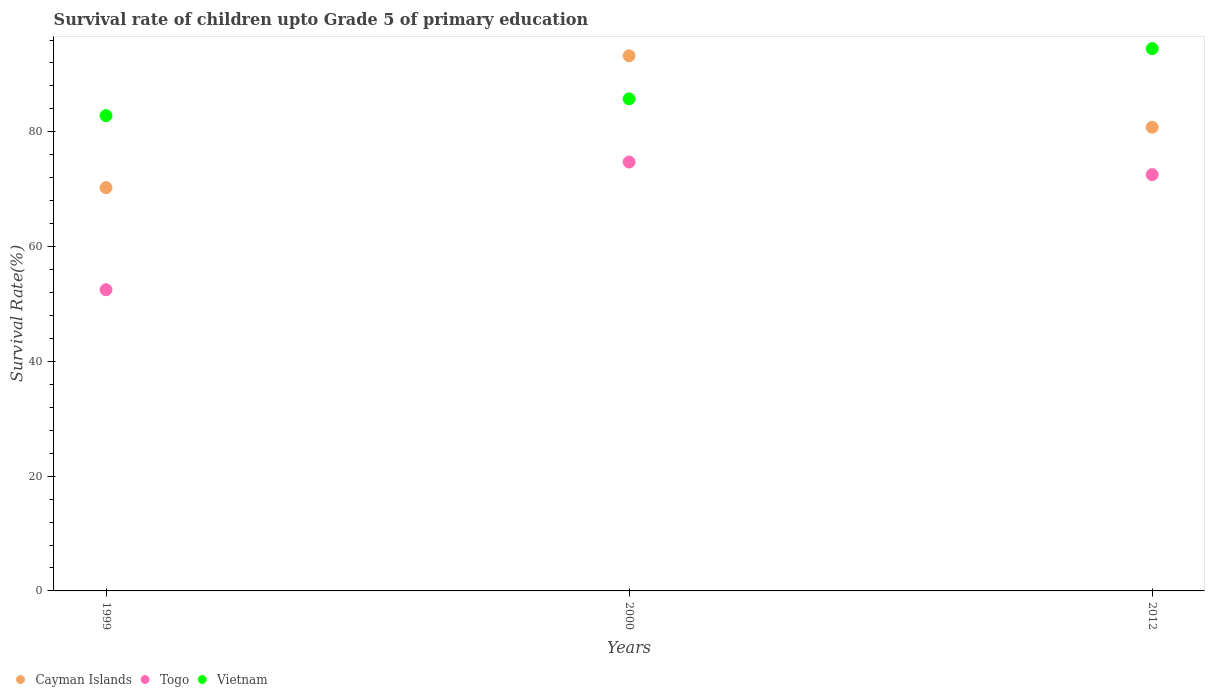Is the number of dotlines equal to the number of legend labels?
Make the answer very short. Yes. What is the survival rate of children in Cayman Islands in 1999?
Provide a succinct answer. 70.28. Across all years, what is the maximum survival rate of children in Togo?
Offer a very short reply. 74.74. Across all years, what is the minimum survival rate of children in Cayman Islands?
Keep it short and to the point. 70.28. In which year was the survival rate of children in Vietnam maximum?
Offer a terse response. 2012. In which year was the survival rate of children in Cayman Islands minimum?
Keep it short and to the point. 1999. What is the total survival rate of children in Vietnam in the graph?
Your answer should be very brief. 263.06. What is the difference between the survival rate of children in Vietnam in 2000 and that in 2012?
Provide a succinct answer. -8.76. What is the difference between the survival rate of children in Togo in 1999 and the survival rate of children in Vietnam in 2000?
Your answer should be very brief. -33.26. What is the average survival rate of children in Vietnam per year?
Your answer should be very brief. 87.69. In the year 2000, what is the difference between the survival rate of children in Cayman Islands and survival rate of children in Vietnam?
Offer a very short reply. 7.5. In how many years, is the survival rate of children in Vietnam greater than 80 %?
Your response must be concise. 3. What is the ratio of the survival rate of children in Vietnam in 1999 to that in 2012?
Make the answer very short. 0.88. Is the survival rate of children in Cayman Islands in 2000 less than that in 2012?
Give a very brief answer. No. Is the difference between the survival rate of children in Cayman Islands in 2000 and 2012 greater than the difference between the survival rate of children in Vietnam in 2000 and 2012?
Ensure brevity in your answer.  Yes. What is the difference between the highest and the second highest survival rate of children in Togo?
Offer a terse response. 2.2. What is the difference between the highest and the lowest survival rate of children in Vietnam?
Offer a terse response. 11.68. In how many years, is the survival rate of children in Cayman Islands greater than the average survival rate of children in Cayman Islands taken over all years?
Your response must be concise. 1. Is the survival rate of children in Vietnam strictly greater than the survival rate of children in Cayman Islands over the years?
Keep it short and to the point. No. Is the survival rate of children in Togo strictly less than the survival rate of children in Vietnam over the years?
Your answer should be compact. Yes. Does the graph contain grids?
Your response must be concise. No. Where does the legend appear in the graph?
Ensure brevity in your answer.  Bottom left. How many legend labels are there?
Your answer should be very brief. 3. How are the legend labels stacked?
Ensure brevity in your answer.  Horizontal. What is the title of the graph?
Keep it short and to the point. Survival rate of children upto Grade 5 of primary education. Does "Czech Republic" appear as one of the legend labels in the graph?
Give a very brief answer. No. What is the label or title of the Y-axis?
Offer a terse response. Survival Rate(%). What is the Survival Rate(%) of Cayman Islands in 1999?
Make the answer very short. 70.28. What is the Survival Rate(%) in Togo in 1999?
Provide a succinct answer. 52.48. What is the Survival Rate(%) of Vietnam in 1999?
Provide a short and direct response. 82.82. What is the Survival Rate(%) of Cayman Islands in 2000?
Make the answer very short. 93.25. What is the Survival Rate(%) in Togo in 2000?
Your answer should be very brief. 74.74. What is the Survival Rate(%) of Vietnam in 2000?
Your answer should be compact. 85.74. What is the Survival Rate(%) of Cayman Islands in 2012?
Ensure brevity in your answer.  80.8. What is the Survival Rate(%) in Togo in 2012?
Make the answer very short. 72.54. What is the Survival Rate(%) in Vietnam in 2012?
Your answer should be very brief. 94.5. Across all years, what is the maximum Survival Rate(%) of Cayman Islands?
Give a very brief answer. 93.25. Across all years, what is the maximum Survival Rate(%) of Togo?
Offer a terse response. 74.74. Across all years, what is the maximum Survival Rate(%) of Vietnam?
Offer a terse response. 94.5. Across all years, what is the minimum Survival Rate(%) in Cayman Islands?
Your response must be concise. 70.28. Across all years, what is the minimum Survival Rate(%) in Togo?
Make the answer very short. 52.48. Across all years, what is the minimum Survival Rate(%) in Vietnam?
Offer a terse response. 82.82. What is the total Survival Rate(%) of Cayman Islands in the graph?
Your answer should be very brief. 244.32. What is the total Survival Rate(%) in Togo in the graph?
Offer a very short reply. 199.76. What is the total Survival Rate(%) in Vietnam in the graph?
Ensure brevity in your answer.  263.06. What is the difference between the Survival Rate(%) of Cayman Islands in 1999 and that in 2000?
Your answer should be compact. -22.97. What is the difference between the Survival Rate(%) in Togo in 1999 and that in 2000?
Make the answer very short. -22.26. What is the difference between the Survival Rate(%) of Vietnam in 1999 and that in 2000?
Make the answer very short. -2.92. What is the difference between the Survival Rate(%) in Cayman Islands in 1999 and that in 2012?
Provide a short and direct response. -10.52. What is the difference between the Survival Rate(%) in Togo in 1999 and that in 2012?
Make the answer very short. -20.06. What is the difference between the Survival Rate(%) in Vietnam in 1999 and that in 2012?
Make the answer very short. -11.68. What is the difference between the Survival Rate(%) in Cayman Islands in 2000 and that in 2012?
Offer a very short reply. 12.45. What is the difference between the Survival Rate(%) in Togo in 2000 and that in 2012?
Your answer should be compact. 2.2. What is the difference between the Survival Rate(%) of Vietnam in 2000 and that in 2012?
Your response must be concise. -8.76. What is the difference between the Survival Rate(%) in Cayman Islands in 1999 and the Survival Rate(%) in Togo in 2000?
Offer a very short reply. -4.46. What is the difference between the Survival Rate(%) of Cayman Islands in 1999 and the Survival Rate(%) of Vietnam in 2000?
Offer a terse response. -15.47. What is the difference between the Survival Rate(%) of Togo in 1999 and the Survival Rate(%) of Vietnam in 2000?
Provide a succinct answer. -33.26. What is the difference between the Survival Rate(%) of Cayman Islands in 1999 and the Survival Rate(%) of Togo in 2012?
Offer a terse response. -2.26. What is the difference between the Survival Rate(%) of Cayman Islands in 1999 and the Survival Rate(%) of Vietnam in 2012?
Your answer should be very brief. -24.22. What is the difference between the Survival Rate(%) in Togo in 1999 and the Survival Rate(%) in Vietnam in 2012?
Provide a succinct answer. -42.02. What is the difference between the Survival Rate(%) in Cayman Islands in 2000 and the Survival Rate(%) in Togo in 2012?
Provide a succinct answer. 20.71. What is the difference between the Survival Rate(%) of Cayman Islands in 2000 and the Survival Rate(%) of Vietnam in 2012?
Make the answer very short. -1.25. What is the difference between the Survival Rate(%) of Togo in 2000 and the Survival Rate(%) of Vietnam in 2012?
Provide a short and direct response. -19.76. What is the average Survival Rate(%) of Cayman Islands per year?
Your answer should be compact. 81.44. What is the average Survival Rate(%) of Togo per year?
Give a very brief answer. 66.59. What is the average Survival Rate(%) in Vietnam per year?
Provide a succinct answer. 87.69. In the year 1999, what is the difference between the Survival Rate(%) of Cayman Islands and Survival Rate(%) of Togo?
Provide a short and direct response. 17.79. In the year 1999, what is the difference between the Survival Rate(%) of Cayman Islands and Survival Rate(%) of Vietnam?
Give a very brief answer. -12.54. In the year 1999, what is the difference between the Survival Rate(%) in Togo and Survival Rate(%) in Vietnam?
Keep it short and to the point. -30.34. In the year 2000, what is the difference between the Survival Rate(%) of Cayman Islands and Survival Rate(%) of Togo?
Make the answer very short. 18.51. In the year 2000, what is the difference between the Survival Rate(%) in Cayman Islands and Survival Rate(%) in Vietnam?
Keep it short and to the point. 7.5. In the year 2000, what is the difference between the Survival Rate(%) in Togo and Survival Rate(%) in Vietnam?
Offer a terse response. -11. In the year 2012, what is the difference between the Survival Rate(%) of Cayman Islands and Survival Rate(%) of Togo?
Keep it short and to the point. 8.26. In the year 2012, what is the difference between the Survival Rate(%) in Cayman Islands and Survival Rate(%) in Vietnam?
Provide a succinct answer. -13.7. In the year 2012, what is the difference between the Survival Rate(%) in Togo and Survival Rate(%) in Vietnam?
Make the answer very short. -21.96. What is the ratio of the Survival Rate(%) in Cayman Islands in 1999 to that in 2000?
Ensure brevity in your answer.  0.75. What is the ratio of the Survival Rate(%) of Togo in 1999 to that in 2000?
Make the answer very short. 0.7. What is the ratio of the Survival Rate(%) of Vietnam in 1999 to that in 2000?
Offer a very short reply. 0.97. What is the ratio of the Survival Rate(%) of Cayman Islands in 1999 to that in 2012?
Make the answer very short. 0.87. What is the ratio of the Survival Rate(%) in Togo in 1999 to that in 2012?
Your response must be concise. 0.72. What is the ratio of the Survival Rate(%) in Vietnam in 1999 to that in 2012?
Give a very brief answer. 0.88. What is the ratio of the Survival Rate(%) of Cayman Islands in 2000 to that in 2012?
Offer a very short reply. 1.15. What is the ratio of the Survival Rate(%) of Togo in 2000 to that in 2012?
Your answer should be very brief. 1.03. What is the ratio of the Survival Rate(%) of Vietnam in 2000 to that in 2012?
Provide a succinct answer. 0.91. What is the difference between the highest and the second highest Survival Rate(%) of Cayman Islands?
Your answer should be very brief. 12.45. What is the difference between the highest and the second highest Survival Rate(%) in Togo?
Make the answer very short. 2.2. What is the difference between the highest and the second highest Survival Rate(%) of Vietnam?
Your answer should be compact. 8.76. What is the difference between the highest and the lowest Survival Rate(%) in Cayman Islands?
Ensure brevity in your answer.  22.97. What is the difference between the highest and the lowest Survival Rate(%) in Togo?
Your response must be concise. 22.26. What is the difference between the highest and the lowest Survival Rate(%) in Vietnam?
Make the answer very short. 11.68. 